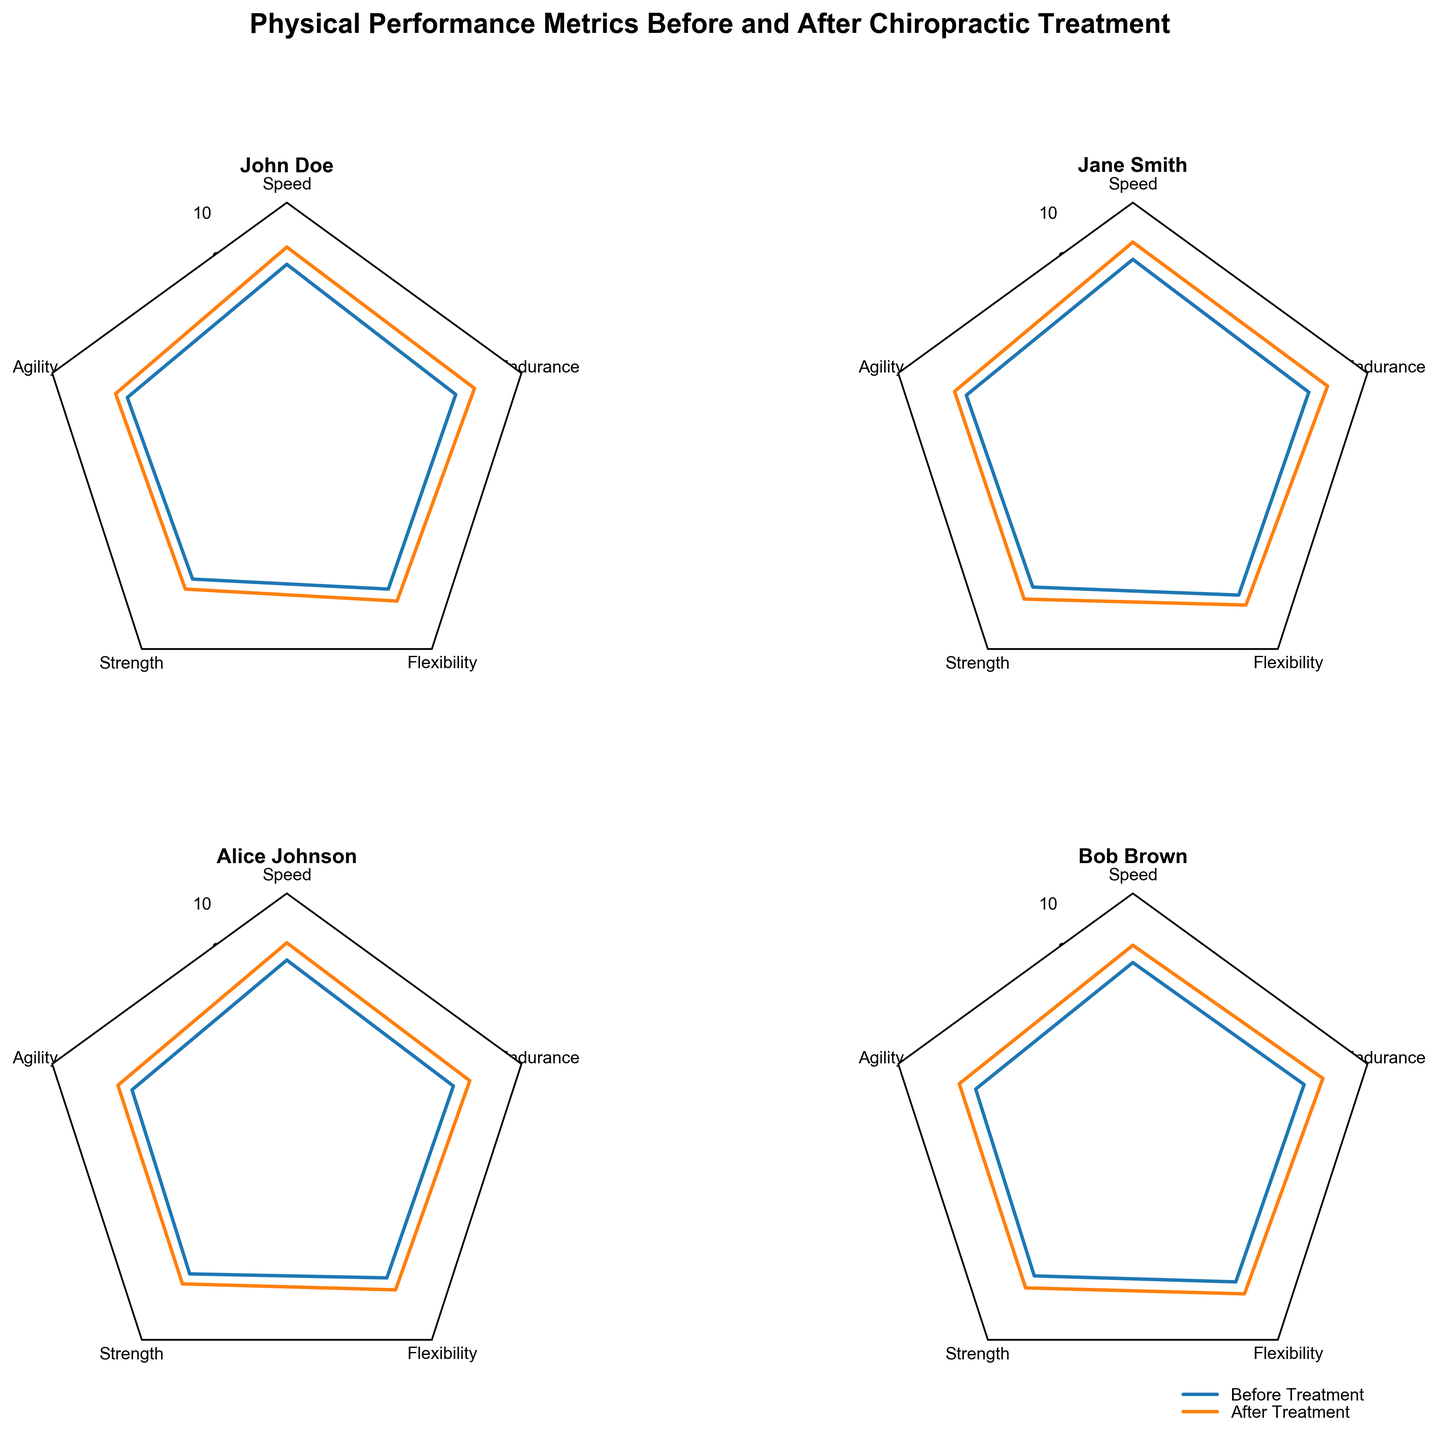How many players are shown in the radar chart subplots? The radar chart subplots show four radar charts, each representing a different player. The players can be identified by their names on the titles of the subplots.
Answer: Four Which player saw the greatest improvement in speed after the chiropractic treatment? To determine the greatest improvement in speed, subtract the "Before" value from the "After" value for each player and compare the differences. For John Doe, it's 0.7; for Jane Smith, it's 0.7; for Alice Johnson, it's 0.7; for Bob Brown, it's 0.7. All players show the same improvement.
Answer: All players (0.7) What is the title of the entire figure? The title of the entire figure is located at the top of the figure. It should describe the overall content of the subplots.
Answer: "Physical Performance Metrics Before and After Chiropractic Treatment" Which player had the highest endurance score after treatment? John Doe's endurance after treatment is 8.0, Jane Smith's is 8.3, Alice Johnson's is 7.8, Bob Brown's is 8.1. By comparing these values, Jane Smith has the highest after-treatment endurance score.
Answer: Jane Smith How did Bob Brown's flexibility change after the treatment? To determine the change in flexibility, subtract the "Before" value from the "After" value for Bob Brown. The flexibility before treatment is 7.1 and after treatment is 7.7. The change is 7.7 - 7.1 = 0.6.
Answer: 0.6 What percentage increase in agility did Alice Johnson experience? Calculate the percentage increase by subtracting the "Before" value from the "After" value, then dividing by the "Before" value and multiplying by 100. For Alice Johnson, the agility before treatment is 6.6 and after treatment is 7.2. The percentage increase is ((7.2 - 6.6) / 6.6) * 100 ≈ 9.09%.
Answer: 9.09% Which metric showed the most consistent improvement across all players? To find the most consistent improvement, compare the difference between the "Before" and "After" values for each metric across all players. Speed and endurance consistently improve by similar amounts in all players. No metric shows exactly the same improvement across all players, but speed and endurance have high consistency in improvement.
Answer: Speed and Endurance Comparing John Doe and Bob Brown, who had a greater overall improvement in physical performance? Sum the improvements across all metrics for both players and compare the totals. For John Doe: (8.2-7.5) + (7.3-6.8) + (7.0-6.5) + (7.6-7.0) + (8.0-7.2) = 0.7 + 0.5 + 0.5 + 0.6 + 0.8 = 3.1. For Bob Brown: (7.9-7.2) + (7.4-6.7) + (7.4-6.8) + (7.7-7.1) + (8.1-7.3) = 0.7 + 0.7 + 0.6 + 0.6 + 0.8 = 3.4. Bob Brown had a greater overall improvement.
Answer: Bob Brown 